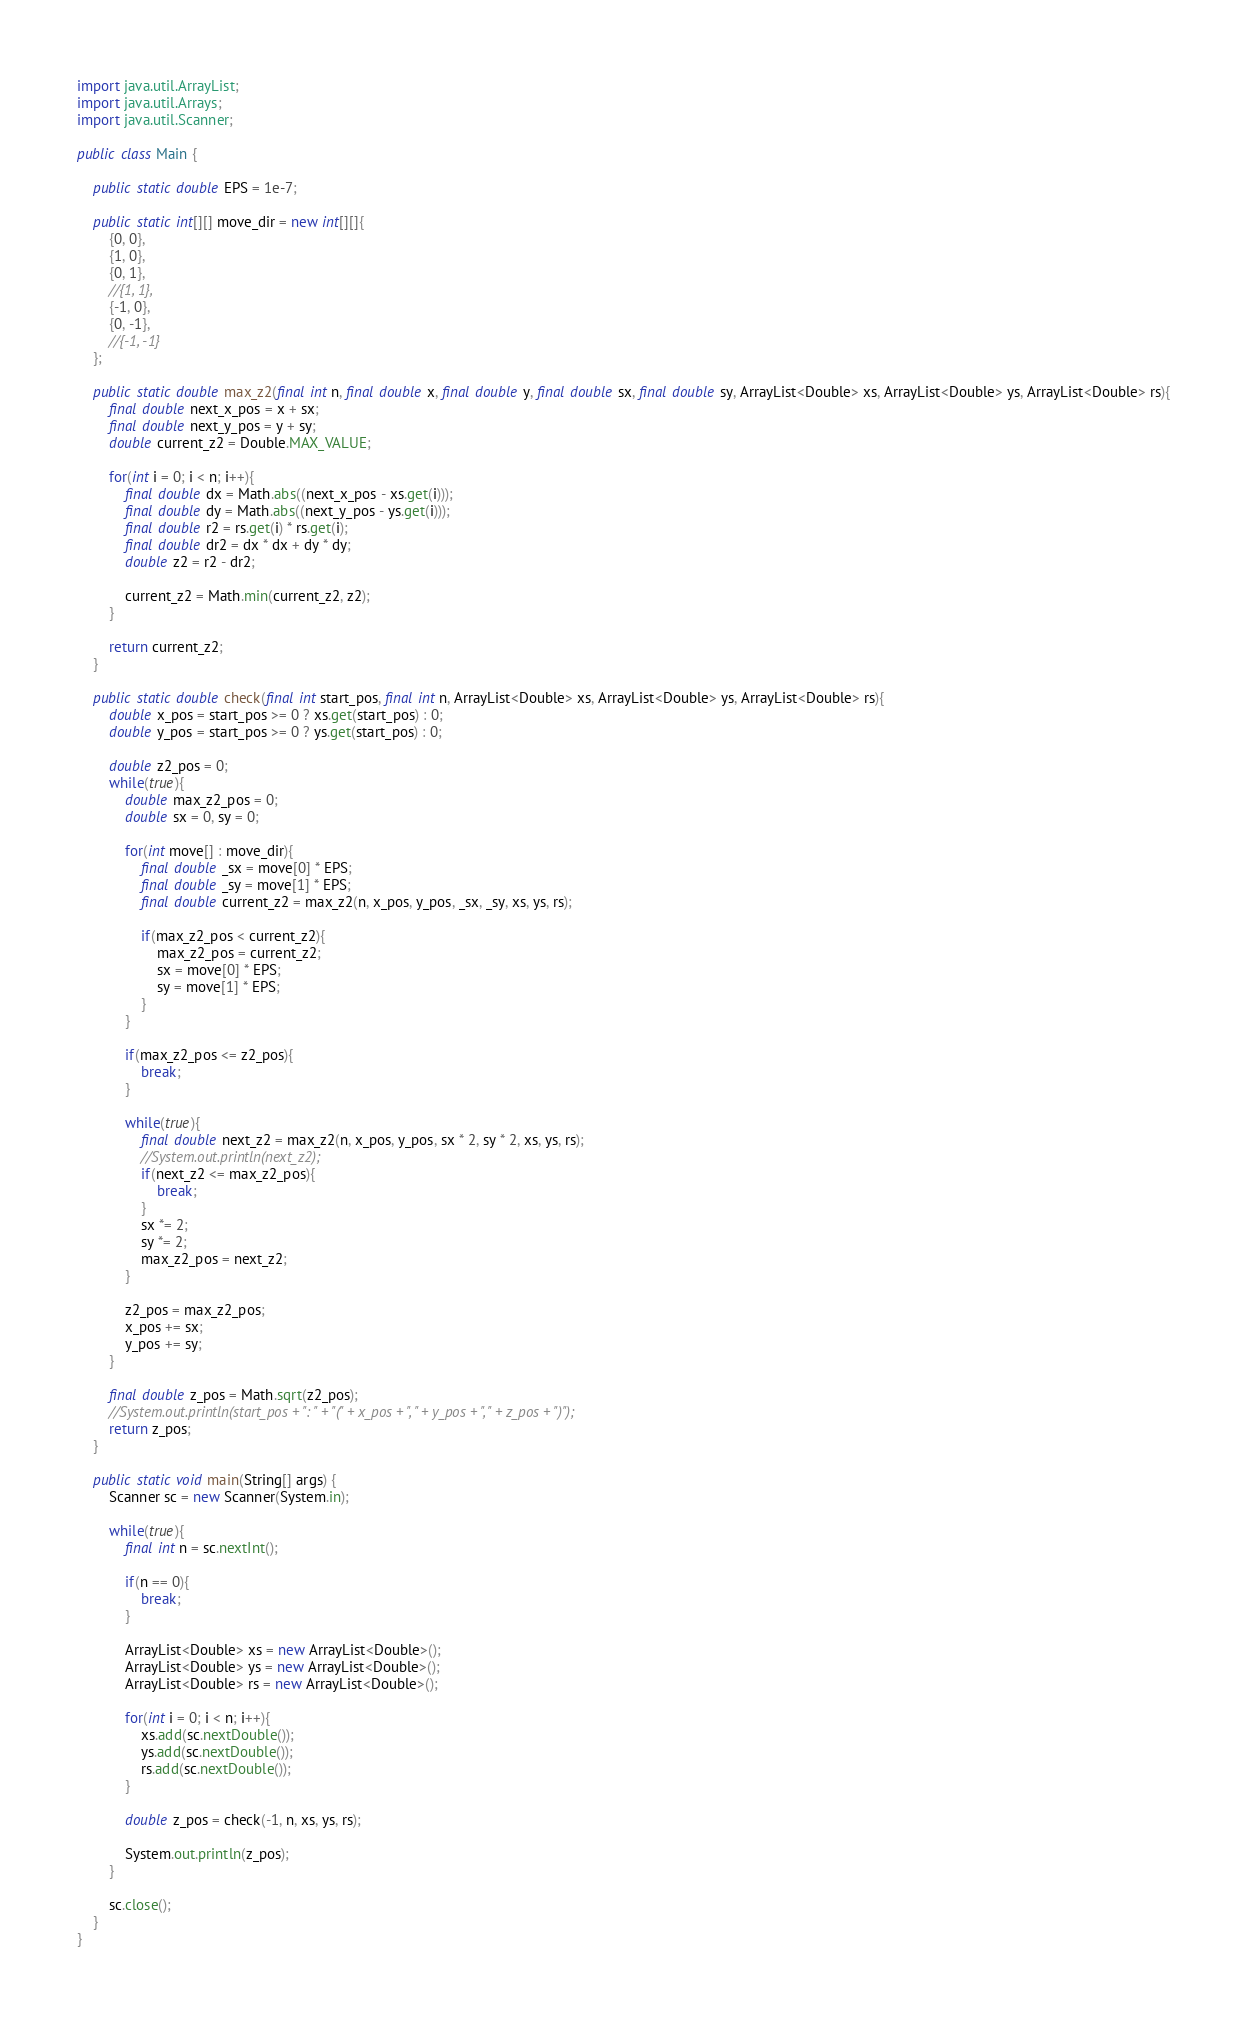Convert code to text. <code><loc_0><loc_0><loc_500><loc_500><_Java_>import java.util.ArrayList;
import java.util.Arrays;
import java.util.Scanner;

public class Main {
	
	public static double EPS = 1e-7;
	
	public static int[][] move_dir = new int[][]{
		{0, 0},
		{1, 0},
		{0, 1},
		//{1, 1},
		{-1, 0},
		{0, -1},
		//{-1, -1}
	};
	
	public static double max_z2(final int n, final double x, final double y, final double sx, final double sy, ArrayList<Double> xs, ArrayList<Double> ys, ArrayList<Double> rs){
		final double next_x_pos = x + sx;
		final double next_y_pos = y + sy;
		double current_z2 = Double.MAX_VALUE;
		
		for(int i = 0; i < n; i++){
			final double dx = Math.abs((next_x_pos - xs.get(i)));
			final double dy = Math.abs((next_y_pos - ys.get(i)));
			final double r2 = rs.get(i) * rs.get(i);
			final double dr2 = dx * dx + dy * dy;
			double z2 = r2 - dr2;
			
			current_z2 = Math.min(current_z2, z2);
		}
		
		return current_z2;
	}
	
	public static double check(final int start_pos, final int n, ArrayList<Double> xs, ArrayList<Double> ys, ArrayList<Double> rs){
		double x_pos = start_pos >= 0 ? xs.get(start_pos) : 0;
		double y_pos = start_pos >= 0 ? ys.get(start_pos) : 0;
		
		double z2_pos = 0;
		while(true){
			double max_z2_pos = 0;
			double sx = 0, sy = 0;
			
			for(int move[] : move_dir){
				final double _sx = move[0] * EPS;
				final double _sy = move[1] * EPS;
				final double current_z2 = max_z2(n, x_pos, y_pos, _sx, _sy, xs, ys, rs);
				
				if(max_z2_pos < current_z2){
					max_z2_pos = current_z2;
					sx = move[0] * EPS;
					sy = move[1] * EPS;
				}
			}
			
			if(max_z2_pos <= z2_pos){
				break;
			}
			
			while(true){
				final double next_z2 = max_z2(n, x_pos, y_pos, sx * 2, sy * 2, xs, ys, rs);
				//System.out.println(next_z2);
				if(next_z2 <= max_z2_pos){
					break;
				}
				sx *= 2;
				sy *= 2;
				max_z2_pos = next_z2;
			}
			
			z2_pos = max_z2_pos;
			x_pos += sx;
			y_pos += sy;
		}
		
		final double z_pos = Math.sqrt(z2_pos);
		//System.out.println(start_pos + ": " + "(" + x_pos + ", " + y_pos + ", " + z_pos + ")");
		return z_pos;
	}
	
	public static void main(String[] args) {
		Scanner sc = new Scanner(System.in);
	
		while(true){
			final int n = sc.nextInt();
		
			if(n == 0){
				break;
			}
			
			ArrayList<Double> xs = new ArrayList<Double>();
			ArrayList<Double> ys = new ArrayList<Double>();
			ArrayList<Double> rs = new ArrayList<Double>();
			
			for(int i = 0; i < n; i++){
				xs.add(sc.nextDouble());
				ys.add(sc.nextDouble());
				rs.add(sc.nextDouble());
			}
			
			double z_pos = check(-1, n, xs, ys, rs);
			
			System.out.println(z_pos);
		}
		
		sc.close();
	}
}</code> 